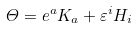<formula> <loc_0><loc_0><loc_500><loc_500>\varTheta = e ^ { a } K _ { a } + \varepsilon ^ { i } H _ { i }</formula> 